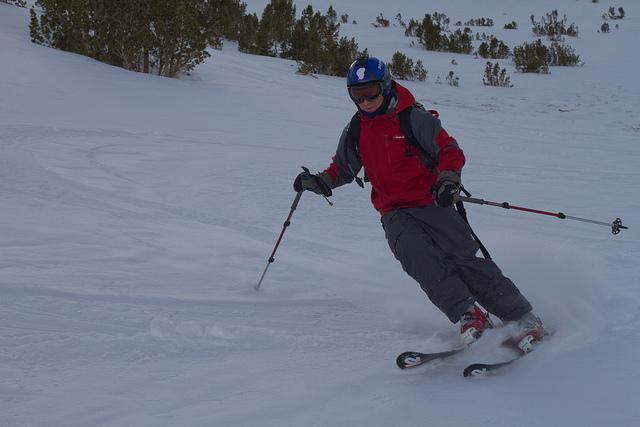How many poles are touching the snow?
Give a very brief answer. 1. How many people are in this picture?
Give a very brief answer. 1. 